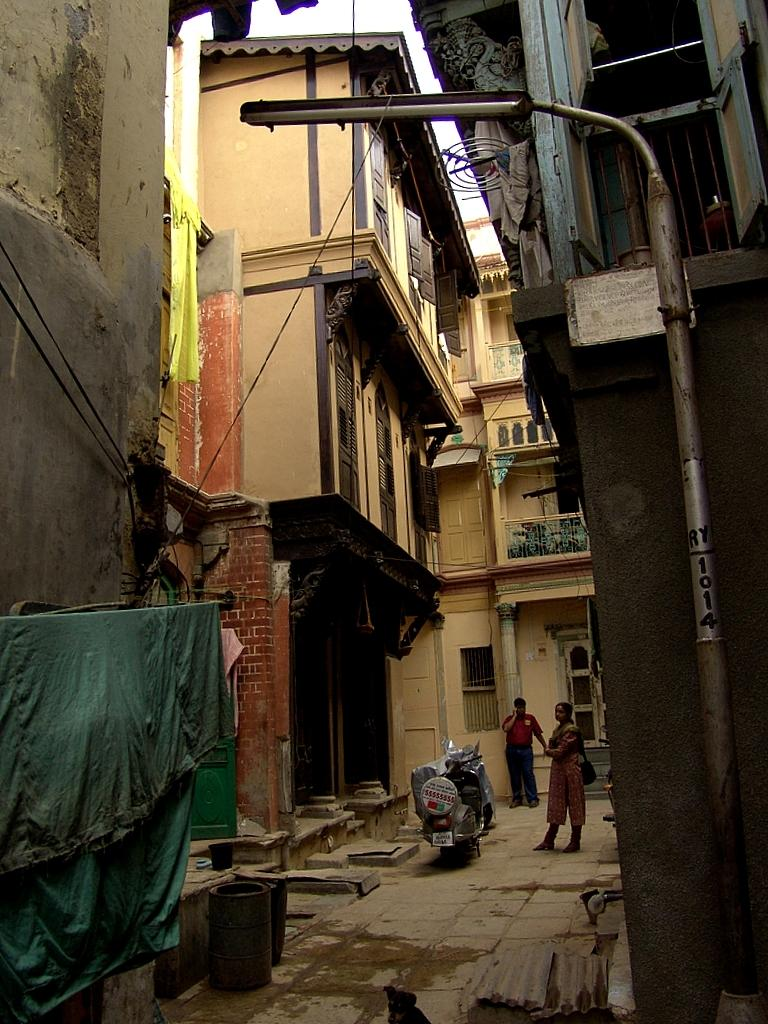What type of structures can be seen in the image? There are buildings in the image. What else is present in the image besides the buildings? There are poles, clothes, motorcycles, and two persons standing near the motorcycles. Can you describe the vehicles in the image? There are motorcycles in the middle of the image. What are the two persons near the motorcycles doing? The two persons are standing near the motorcycles. Can you tell me how many cows are present in the image? There are no cows present in the image. What type of event is taking place in the image? There is no event depicted in the image; it shows buildings, poles, clothes, motorcycles, and two persons standing near the motorcycles. 